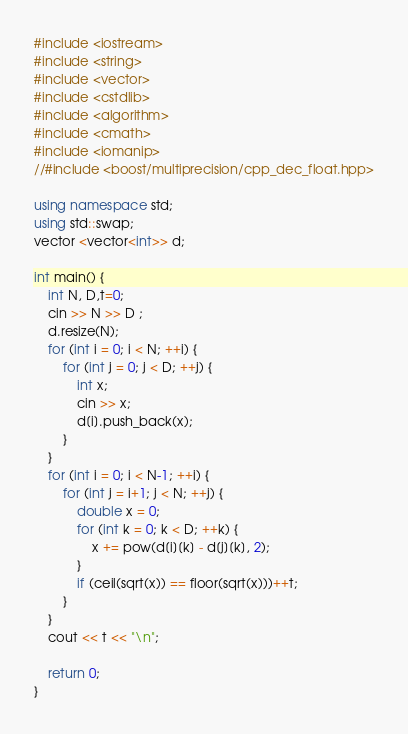<code> <loc_0><loc_0><loc_500><loc_500><_C++_>#include <iostream>
#include <string>
#include <vector>
#include <cstdlib>
#include <algorithm>
#include <cmath>
#include <iomanip>
//#include <boost/multiprecision/cpp_dec_float.hpp>

using namespace std;
using std::swap;
vector <vector<int>> d;

int main() {
	int N, D,t=0;
	cin >> N >> D ;
	d.resize(N);
	for (int i = 0; i < N; ++i) {
		for (int j = 0; j < D; ++j) {
			int x;
			cin >> x;
			d[i].push_back(x);
		}
	}
	for (int i = 0; i < N-1; ++i) {
		for (int j = i+1; j < N; ++j) {
			double x = 0;
			for (int k = 0; k < D; ++k) {
				x += pow(d[i][k] - d[j][k], 2);
			}
			if (ceil(sqrt(x)) == floor(sqrt(x)))++t;
		}
	}
	cout << t << "\n";

	return 0;
}</code> 